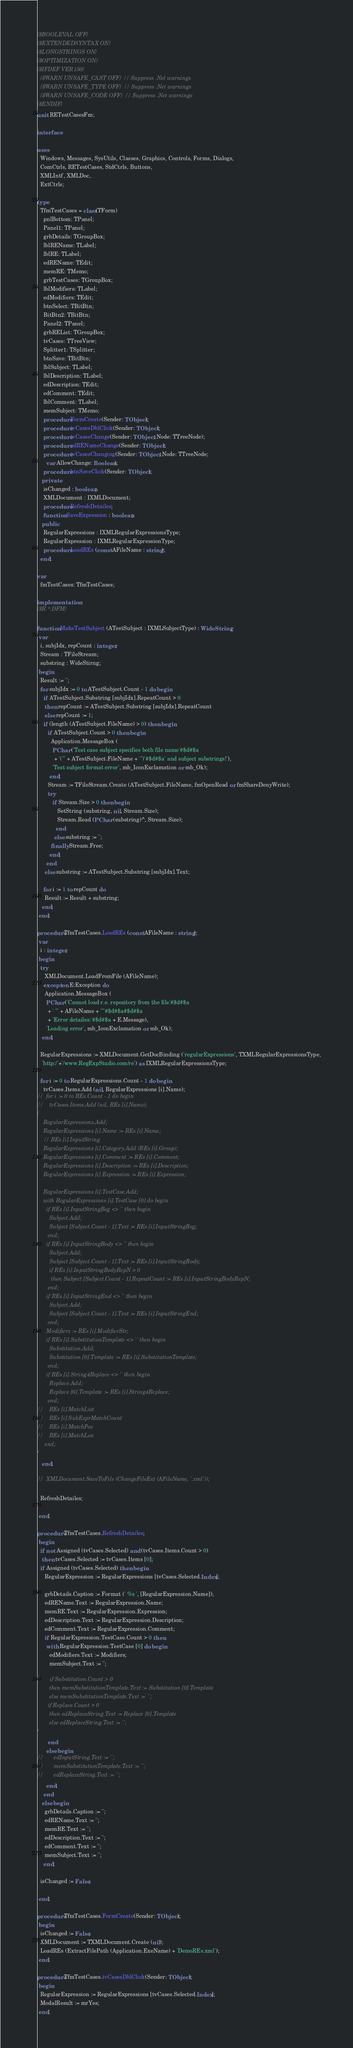<code> <loc_0><loc_0><loc_500><loc_500><_Pascal_>{$BOOLEVAL OFF}
{$EXTENDEDSYNTAX ON}
{$LONGSTRINGS ON}
{$OPTIMIZATION ON}
{$IFDEF VER150}
  {$WARN UNSAFE_CAST OFF} // Suppress .Net warnings
  {$WARN UNSAFE_TYPE OFF} // Suppress .Net warnings
  {$WARN UNSAFE_CODE OFF} // Suppress .Net warnings
{$ENDIF}
unit RETestCasesFm;

interface

uses
  Windows, Messages, SysUtils, Classes, Graphics, Controls, Forms, Dialogs,
  ComCtrls, RETestCases, StdCtrls, Buttons,
  XMLIntf, XMLDoc,
  ExtCtrls;

type
  TfmTestCases = class(TForm)
    pnlBottom: TPanel;
    Panel1: TPanel;
    grbDetails: TGroupBox;
    lblREName: TLabel;
    lblRE: TLabel;
    edREName: TEdit;
    memRE: TMemo;
    grbTestCases: TGroupBox;
    lblModifiers: TLabel;
    edModifiers: TEdit;
    btnSelect: TBitBtn;
    BitBtn2: TBitBtn;
    Panel2: TPanel;
    grbREList: TGroupBox;
    tvCases: TTreeView;
    Splitter1: TSplitter;
    btnSave: TBitBtn;
    lblSubject: TLabel;
    lblDescription: TLabel;
    edDescription: TEdit;
    edComment: TEdit;
    lblComment: TLabel;
    memSubject: TMemo;
    procedure FormCreate(Sender: TObject);
    procedure tvCasesDblClick(Sender: TObject);
    procedure tvCasesChange(Sender: TObject; Node: TTreeNode);
    procedure edRENameChange(Sender: TObject);
    procedure tvCasesChanging(Sender: TObject; Node: TTreeNode;
      var AllowChange: Boolean);
    procedure btnSaveClick(Sender: TObject);
   private
    isChanged : boolean;
    XMLDocument : IXMLDocument;
    procedure RefreshDetailes;
    function SaveExpression : boolean;
   public
    RegularExpressions : IXMLRegularExpressionsType;
    RegularExpression : IXMLRegularExpressionType;
    procedure LoadREs (const AFileName : string);
  end;

var
  fmTestCases: TfmTestCases;

implementation
{$R *.DFM}

function MakeTestSubject (ATestSubject : IXMLSubjectType) : WideString;
 var
  i, subjIdx, repCount : integer;
  Stream : TFileStream;
  substring : WideStirng;
 begin
  Result := '';
  for subjIdx := 0 to ATestSubject.Count - 1 do begin
    if ATestSubject.Substring [subjIdx].RepeatCount > 0
     then repCount := ATestSubject.Substring [subjIdx].RepeatCount
     else repCount := 1;
    if (length (ATestSubject.FileName) > 0) then begin
       if ATestSubject.Count > 0 then begin
         Application.MessageBox (
          PChar ('Test case subject specifies both file name'#$d#$a
           + '("' + ATestSubject.FileName + '")'#$d#$a' and subject substrings!'),
          'Test subject format error', mb_IconExclamation or mb_Ok);
        end;
       Stream := TFileStream.Create (ATestSubject.FileName, fmOpenRead or fmShareDenyWrite);
       try
          if Stream.Size > 0 then begin
             SetString (substring, nil, Stream.Size);
             Stream.Read (PChar (substring)^, Stream.Size);
            end
           else substring := '';
         finally Stream.Free;
        end;
      end
     else substring := ATestSubject.Substring [subjIdx].Text;

    for i := 1 to repCount do
     Result := Result + substring;
   end;
 end;

procedure TfmTestCases.LoadREs (const AFileName : string);
 var
  i : integer;
 begin
  try
     XMLDocument.LoadFromFile (AFileName);
    except on E:Exception do
     Application.MessageBox (
      PChar ('Cannot load r.e. repository from the file'#$d#$a
       + ' "' + AFileName + '"'#$d#$a#$d#$a
       + 'Error detailes:'#$d#$a + E.Message),
      'Loading error', mb_IconExclamation or mb_Ok);
   end;

  RegularExpressions := XMLDocument.GetDocBinding ('regularExpressions', TXMLRegularExpressionsType,
   'http:/'+'/www.RegExpStudio.com/re') as IXMLRegularExpressionsType;

  for i := 0 to RegularExpressions.Count - 1 do begin
    tvCases.Items.Add (nil, RegularExpressions [i].Name);
//  for i := 0 to REs.Count - 1 do begin
//    tvCases.Items.Add (nil, REs [i].Name);
{
    RegularExpressions.Add;
    RegularExpressions [i].Name := REs [i].Name;
    // REs [i].InputString
    RegularExpressions [i].Category.Add (REs [i].Group);
    RegularExpressions [i].Comment := REs [i].Comment;
    RegularExpressions [i].Description := REs [i].Description;
    RegularExpressions [i].Expression := REs [i].Expression;

    RegularExpressions [i].TestCase.Add;
    with RegularExpressions [i].TestCase [0] do begin
      if REs [i].InputStringBeg <> '' then begin
        Subject.Add;
        Subject [Subject.Count - 1].Text := REs [i].InputStringBeg;
       end;
      if REs [i].InputStringBody <> '' then begin
        Subject.Add;
        Subject [Subject.Count - 1].Text := REs [i].InputStringBody;
        if REs [i].InputStringBodyRepN > 0
         then Subject [Subject.Count - 1].RepeatCount := REs [i].InputStringBodyRepN;
       end;
      if REs [i].InputStringEnd <> '' then begin
        Subject.Add;
        Subject [Subject.Count - 1].Text := REs [i].InputStringEnd;
       end;
      Modifiers := REs [i].ModifierStr;
      if REs [i].SubstitutionTemplate <> '' then begin
        Substitution.Add;
        Substitution [0].Template := REs [i].SubstitutionTemplate;
       end;
      if REs [i].String4Replace <> '' then begin
        Replace.Add;
        Replace [0].Template := REs [i].String4Replace;
       end;
//    REs [i].MatchList
//    REs [i].SubExprMatchCount
//    REs [i].MatchPos
//    REs [i].MatchLen
     end;
}
   end;

//  XMLDocument.SaveToFile (ChangeFileExt (AFileName, '.xml'));

  RefreshDetailes;

 end;

procedure TfmTestCases.RefreshDetailes;
 begin
  if not Assigned (tvCases.Selected) and (tvCases.Items.Count > 0)
   then tvCases.Selected := tvCases.Items [0];
  if Assigned (tvCases.Selected) then begin
     RegularExpression := RegularExpressions [tvCases.Selected.Index];

     grbDetails.Caption := Format (' %s ', [RegularExpression.Name]);
     edREName.Text := RegularExpression.Name;
     memRE.Text := RegularExpression.Expression;
     edDescription.Text := RegularExpression.Description;
     edComment.Text := RegularExpression.Comment;
     if RegularExpression.TestCase.Count > 0 then
      with RegularExpression.TestCase [0] do begin
        edModifiers.Text := Modifiers;
        memSubject.Text := '';

{       if Substitution.Count > 0
        then memSubstitutionTemplate.Text := Substitution [0].Template
        else memSubstitutionTemplate.Text := '';
       if Replace.Count > 0
        then edReplaceString.Text := Replace [0].Template
        else edReplaceString.Text := '';
}
       end
      else begin
//       edInputString.Text := '';
//       memSubstitutionTemplate.Text := '';
//       edReplaceString.Text := '';
      end;
    end
   else begin
     grbDetails.Caption := '';
     edREName.Text := '';
     memRE.Text := '';
     edDescription.Text := '';
     edComment.Text := '';
     memSubject.Text := '';
    end;

  isChanged := False;

 end;

procedure TfmTestCases.FormCreate(Sender: TObject);
 begin
  isChanged := False;
  XMLDocument := TXMLDocument.Create (nil);
  LoadREs (ExtractFilePath (Application.ExeName) + 'DemoREs.xml');
 end;

procedure TfmTestCases.tvCasesDblClick(Sender: TObject);
 begin
  RegularExpression := RegularExpressions [tvCases.Selected.Index];
  ModalResult := mrYes;
 end;
</code> 